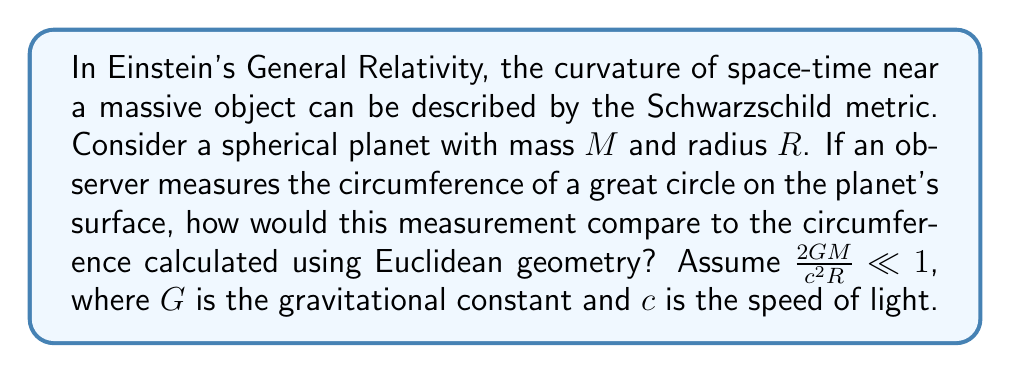Give your solution to this math problem. Let's approach this step-by-step:

1) In Euclidean geometry, the circumference of a circle is given by $C = 2\pi r$, where $r$ is the radius.

2) In General Relativity, space-time is curved near massive objects. The Schwarzschild metric describes this curvature:

   $$ds^2 = -\left(1-\frac{2GM}{c^2r}\right)c^2dt^2 + \left(1-\frac{2GM}{c^2r}\right)^{-1}dr^2 + r^2(d\theta^2 + \sin^2\theta d\phi^2)$$

3) For a great circle on the surface, $r = R$ (constant) and $\theta = \pi/2$ (constant). The circumference is found by integrating $ds$ around the equator ($\phi$ from 0 to $2\pi$):

   $$C_{GR} = \int_0^{2\pi} \sqrt{R^2 d\phi^2} = 2\pi R$$

4) This seems to give the same result as Euclidean geometry, but we need to consider that $R$ in the Schwarzschild metric is not the same as the radial coordinate an observer would measure.

5) The proper radial distance from the center to the surface is:

   $$L = \int_0^R \left(1-\frac{2GM}{c^2r}\right)^{-1/2} dr$$

6) Expanding this for small $\frac{2GM}{c^2R}$:

   $$L \approx R \left(1 + \frac{GM}{c^2R}\right)$$

7) The ratio of the circumference to the proper diameter is:

   $$\frac{C_{GR}}{2L} \approx \frac{2\pi R}{2R(1 + \frac{GM}{c^2R})} \approx \pi \left(1 - \frac{GM}{c^2R}\right)$$

8) Compared to the Euclidean value of $\pi$, this ratio is slightly smaller, indicating that the measured circumference would be slightly less than expected in Euclidean geometry.
Answer: The measured circumference would be slightly less than $2\pi R$, approximately by a factor of $\left(1 - \frac{GM}{c^2R}\right)$. 